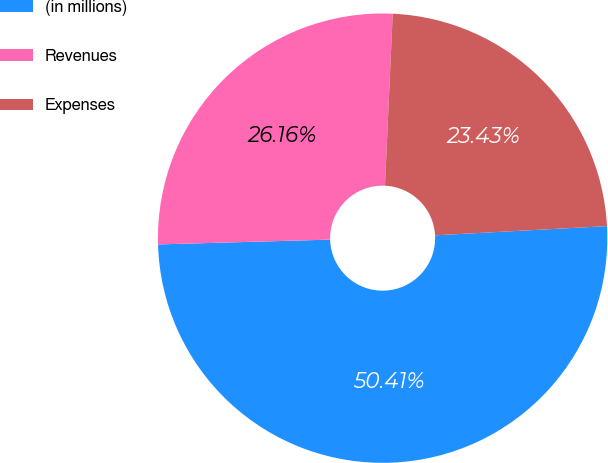Convert chart to OTSL. <chart><loc_0><loc_0><loc_500><loc_500><pie_chart><fcel>(in millions)<fcel>Revenues<fcel>Expenses<nl><fcel>50.41%<fcel>26.16%<fcel>23.43%<nl></chart> 